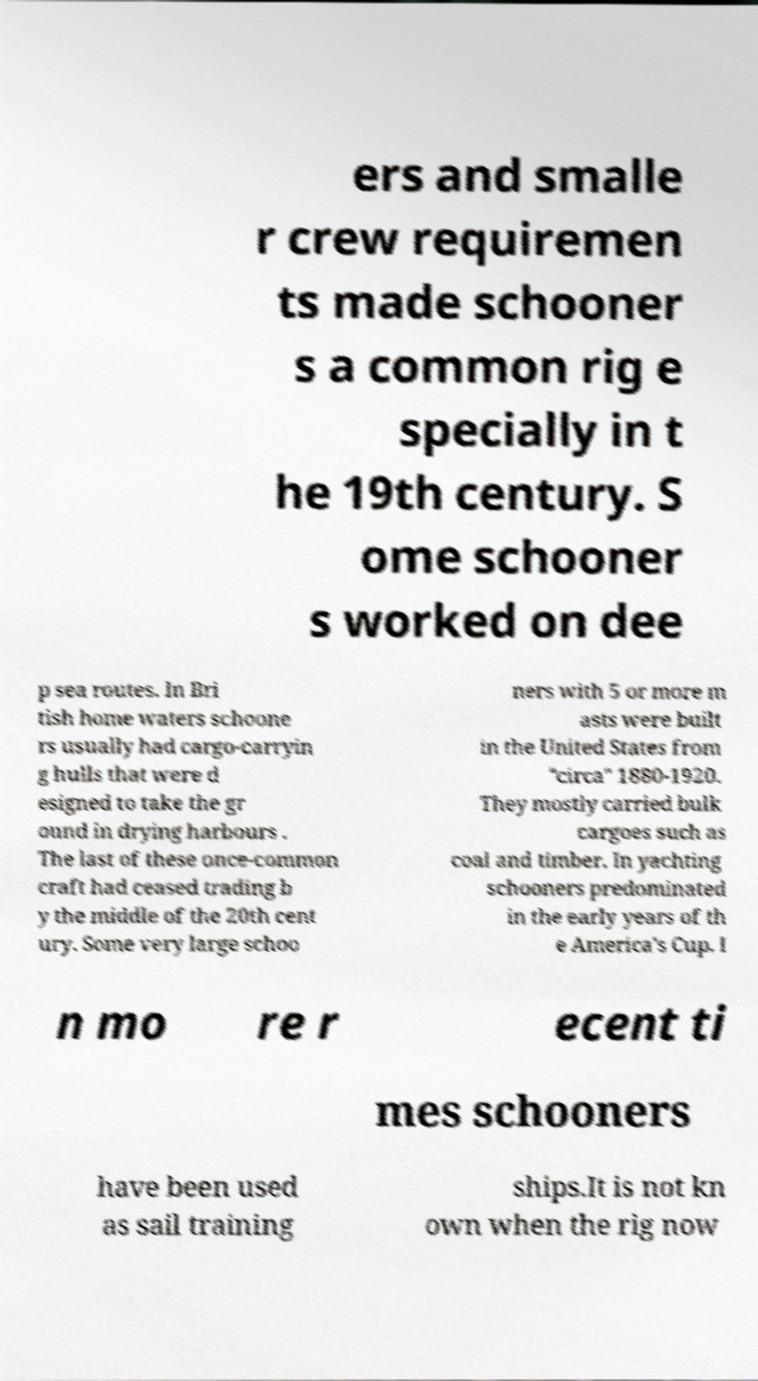Could you extract and type out the text from this image? ers and smalle r crew requiremen ts made schooner s a common rig e specially in t he 19th century. S ome schooner s worked on dee p sea routes. In Bri tish home waters schoone rs usually had cargo-carryin g hulls that were d esigned to take the gr ound in drying harbours . The last of these once-common craft had ceased trading b y the middle of the 20th cent ury. Some very large schoo ners with 5 or more m asts were built in the United States from "circa" 1880-1920. They mostly carried bulk cargoes such as coal and timber. In yachting schooners predominated in the early years of th e America's Cup. I n mo re r ecent ti mes schooners have been used as sail training ships.It is not kn own when the rig now 